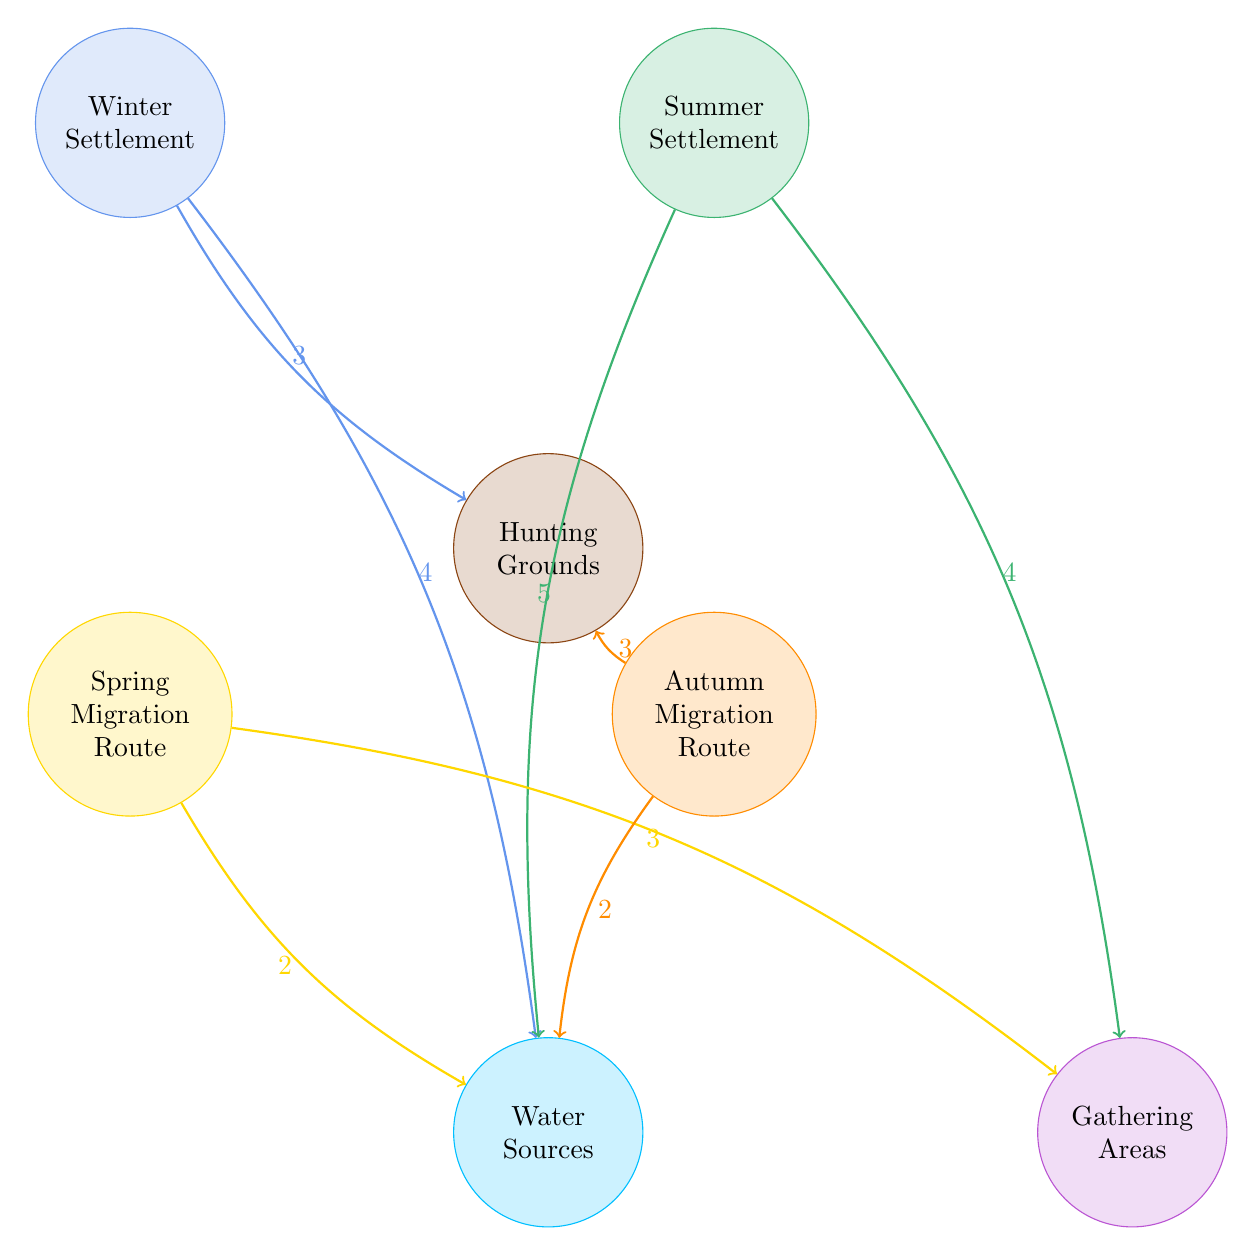What are the links related to Winter Settlement? The Winter Settlement links to two areas: Water Sources with a value of 4 and Hunting Grounds with a value of 3. More specifically, I identify these connections by examining the outgoing links from the Winter Settlement node in the diagram.
Answer: Water Sources, Hunting Grounds How many total nodes are in the diagram? The diagram consists of a total of 7 nodes, which I determined by counting each unique circle representing a settlement, migration route, or resource in the diagram.
Answer: 7 Which settlement has the highest connection to Water Sources? The Summer Settlement has the highest connection to Water Sources with a value of 5. I arrived at this conclusion by comparing the link values for Water Sources from both Winter and Summer Settlements, identifying the higher value.
Answer: Summer Settlement What is the value of the link from Autumn Migration Route to Hunting Grounds? The Autumn Migration Route has a link to Hunting Grounds with a value of 3. This value is directly visible on the arrow connecting these two nodes in the diagram.
Answer: 3 Which migration route has the least connection to Water Sources? The Spring Migration Route has the least connection to Water Sources, with a value of 2. I determined this by comparing its link value with the values of other routes connected to Water Sources in the diagram.
Answer: 2 How many links does Summer Settlement have? The Summer Settlement has two links: one to Water Sources (value of 5) and one to Gathering Areas (value of 4). I counted these links by looking at the outgoing connections from the Summer Settlement node in the diagram.
Answer: 2 Which resource has the highest connection from the Winter Settlement? Hunting Grounds have the highest connection from the Winter Settlement with a value of 3. To find this, I compared the outgoing links from the Winter Settlement and noted the highest value.
Answer: Hunting Grounds What are the values associated with Spring Migration Route? The Spring Migration Route has two outgoing links: 2 to Water Sources and 3 to Gathering Areas. I found these values by examining the connections originating from the Spring Migration Route node.
Answer: 2, 3 